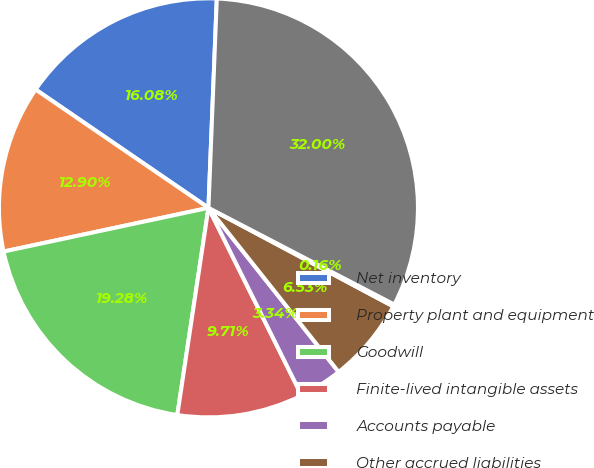<chart> <loc_0><loc_0><loc_500><loc_500><pie_chart><fcel>Net inventory<fcel>Property plant and equipment<fcel>Goodwill<fcel>Finite-lived intangible assets<fcel>Accounts payable<fcel>Other accrued liabilities<fcel>Other long-term liabilities<fcel>Total net assets acquired<nl><fcel>16.08%<fcel>12.9%<fcel>19.28%<fcel>9.71%<fcel>3.34%<fcel>6.53%<fcel>0.16%<fcel>32.0%<nl></chart> 